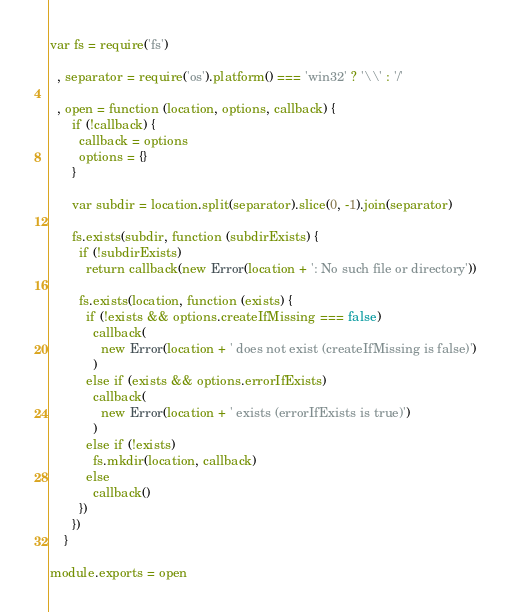<code> <loc_0><loc_0><loc_500><loc_500><_JavaScript_>var fs = require('fs')

  , separator = require('os').platform() === 'win32' ? '\\' : '/'

  , open = function (location, options, callback) {
      if (!callback) {
        callback = options
        options = {}
      }

      var subdir = location.split(separator).slice(0, -1).join(separator)

      fs.exists(subdir, function (subdirExists) {
        if (!subdirExists)
          return callback(new Error(location + ': No such file or directory'))

        fs.exists(location, function (exists) {
          if (!exists && options.createIfMissing === false)
            callback(
              new Error(location + ' does not exist (createIfMissing is false)')
            )
          else if (exists && options.errorIfExists)
            callback(
              new Error(location + ' exists (errorIfExists is true)')
            )
          else if (!exists)
            fs.mkdir(location, callback)
          else
            callback()
        })
      })
    }

module.exports = open
</code> 